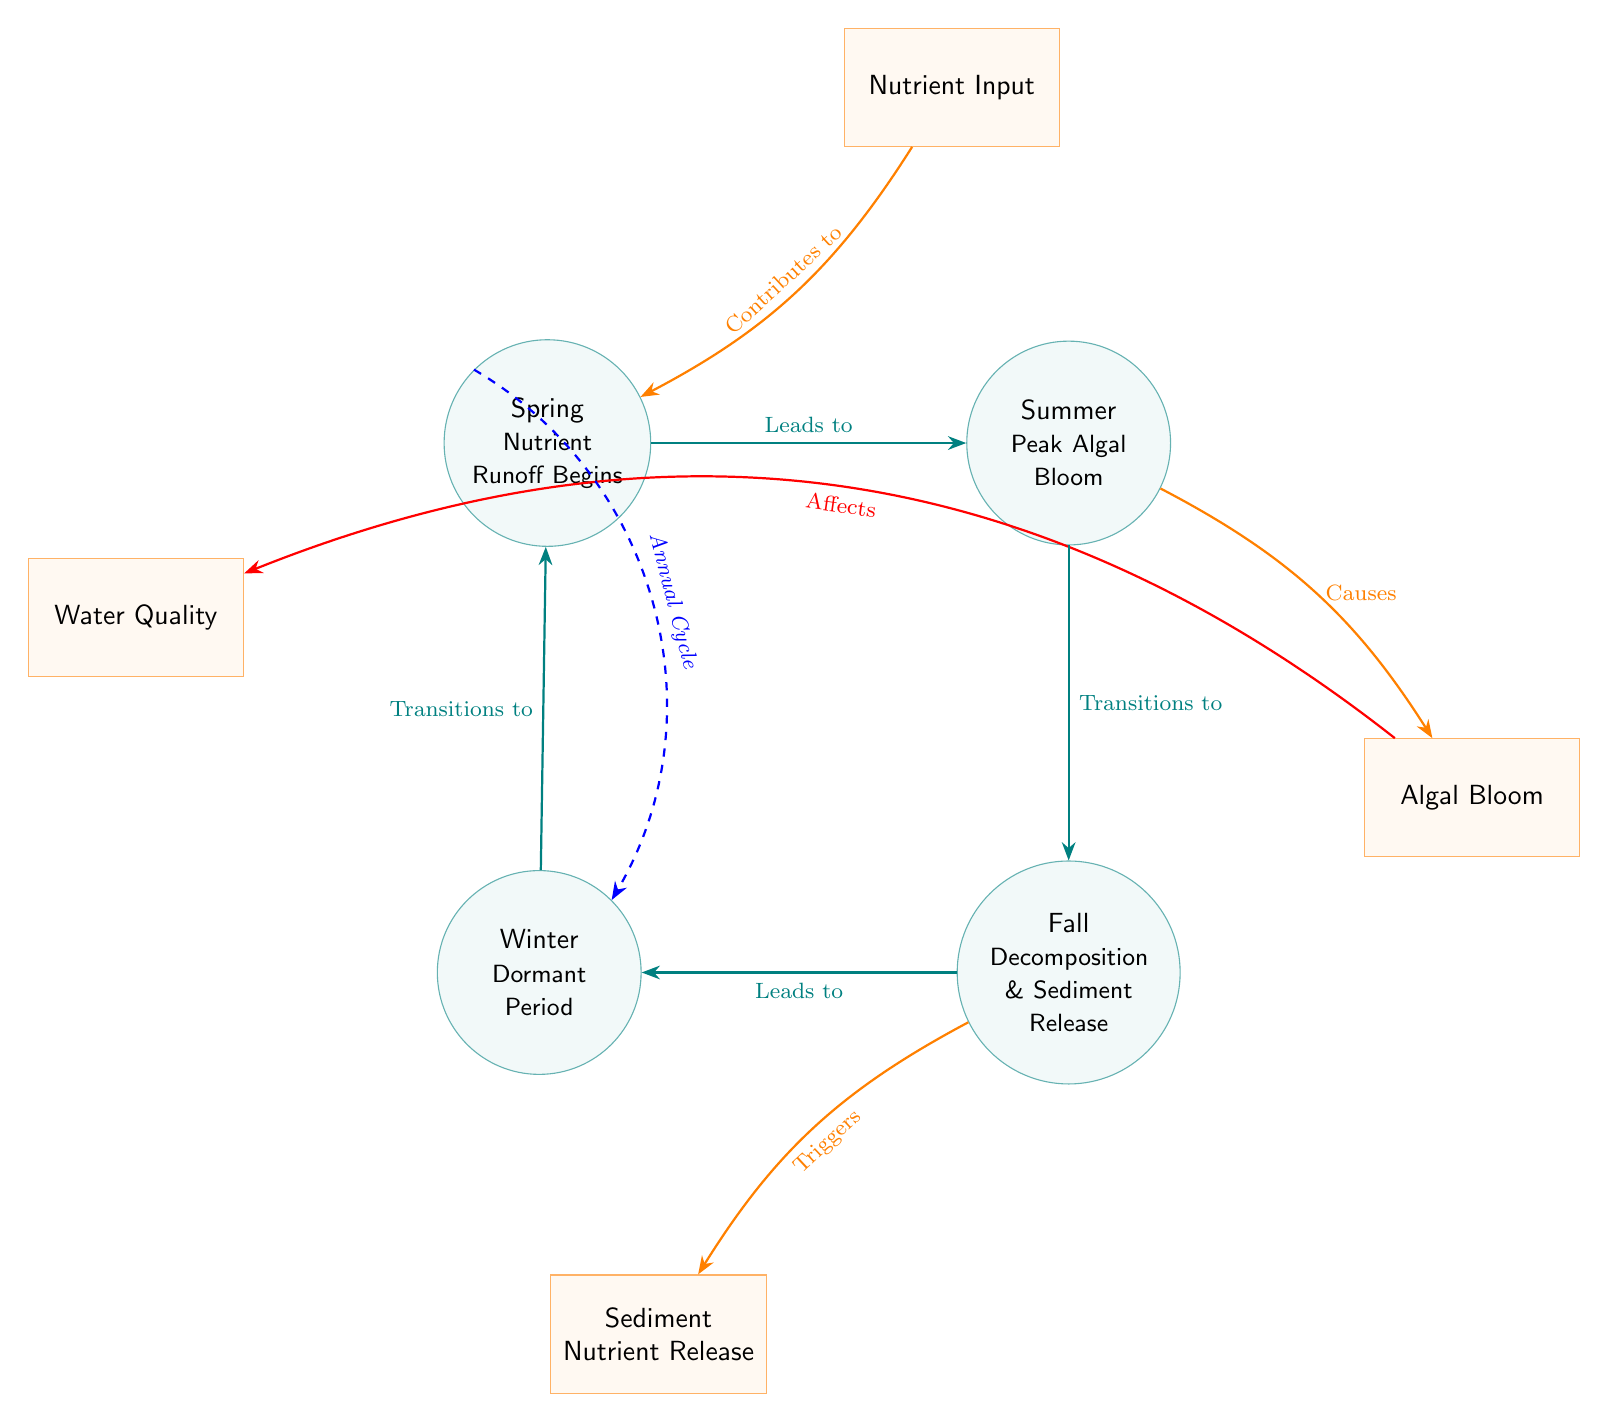What season marks the beginning of nutrient runoff? The diagram labels "Spring" as the season where nutrient runoff begins, making it clear that this is the starting point in the seasonal cycle depicted.
Answer: Spring How many processes are connected to the "Fall" season? In the diagram, "Fall" is connected to two processes: "Triggers Sediment Nutrient Release" and "Leads to Winter." This indicates that there are two distinct processes associated with "Fall."
Answer: 2 What does algal bloom affect according to the diagram? The arrow from "Algal Bloom" points to "Water Quality," indicating that algal blooms have a direct effect on the quality of the water in the lake ecosystem.
Answer: Water Quality Which season has the peak occurrence of algal blooms? The diagram explicitly identifies "Summer" as the season where peak algal blooms occur, highlighting it as the critical point for such events.
Answer: Summer What is the transition from Winter to Spring in the diagram? The diagram shows that "Winter" transitions to "Spring," indicating a cyclical pattern where the dormant period leads back to the beginning of nutrient runoff.
Answer: Transitions to What role does nutrient input play in relation to Spring? According to the diagram, nutrient input contributes to "Spring," thereby establishing that nutrient input is a necessary precursor to the seasonal changes occurring in this period.
Answer: Contributes to What happens to sediment nutrients during the Fall season? The diagram indicates that "Fall" triggers "Sediment Nutrient Release," which means that during this season, the nutrients previously settled in sediments are released back into the water.
Answer: Triggers How does the diagram illustrate the annual cycle? The diagram includes a dashed blue arrow that indicates a cyclical connection from "Spring" to "Winter," thus visually representing the annual cycle of seasonal eutrophication trends.
Answer: Annual Cycle 